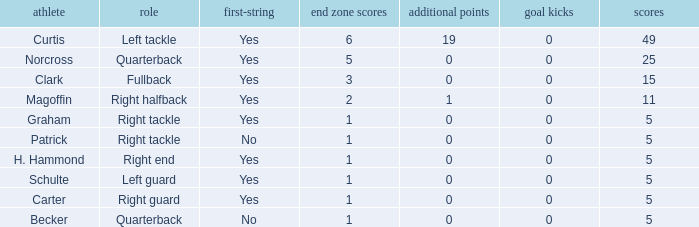Name the most touchdowns for becker  1.0. 